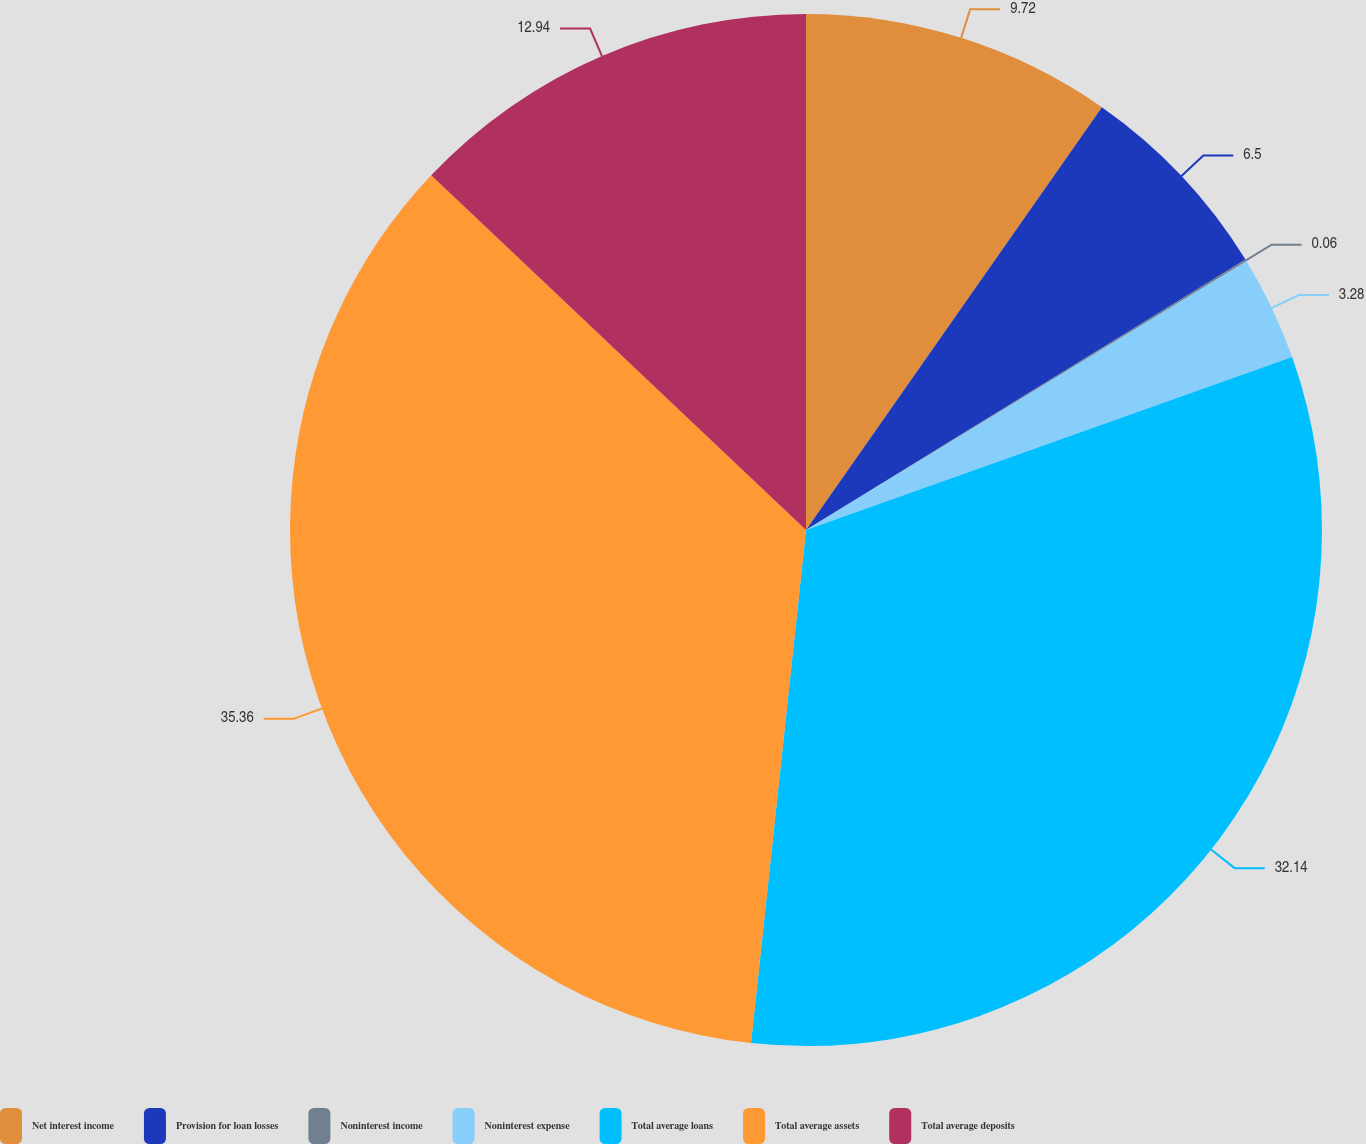Convert chart to OTSL. <chart><loc_0><loc_0><loc_500><loc_500><pie_chart><fcel>Net interest income<fcel>Provision for loan losses<fcel>Noninterest income<fcel>Noninterest expense<fcel>Total average loans<fcel>Total average assets<fcel>Total average deposits<nl><fcel>9.72%<fcel>6.5%<fcel>0.06%<fcel>3.28%<fcel>32.14%<fcel>35.36%<fcel>12.94%<nl></chart> 